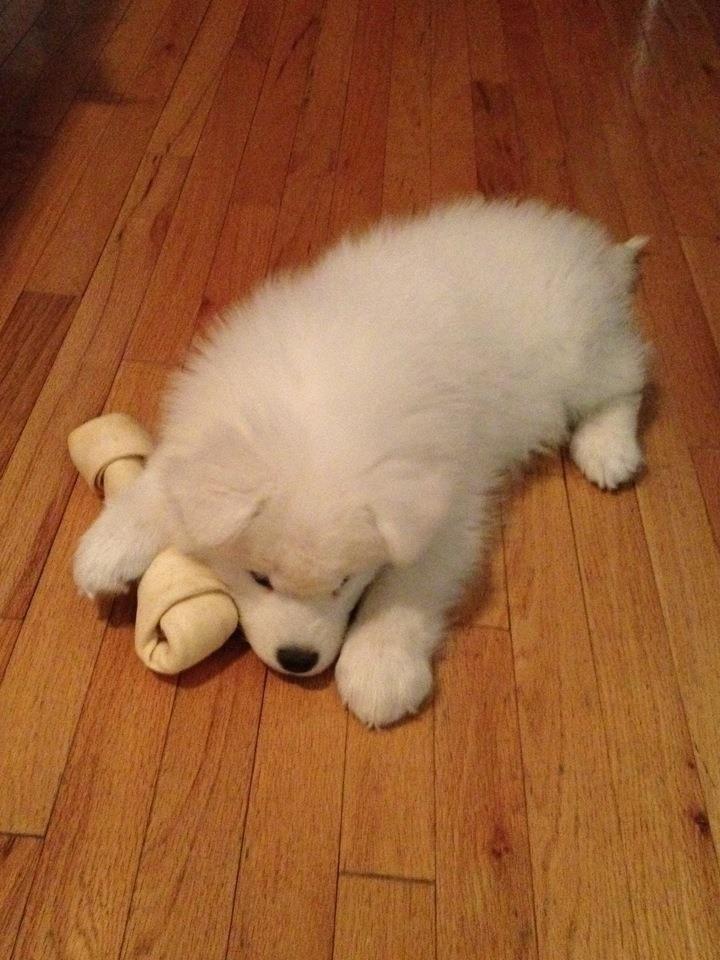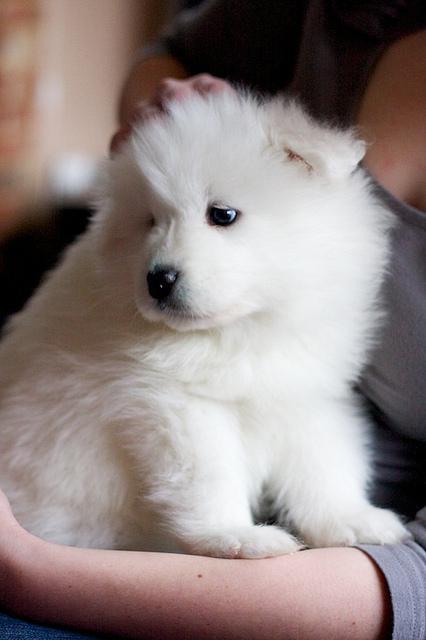The first image is the image on the left, the second image is the image on the right. Analyze the images presented: Is the assertion "one of the pictures has a human arm in it" valid? Answer yes or no. Yes. The first image is the image on the left, the second image is the image on the right. Examine the images to the left and right. Is the description "One of the white dogs is awake and with a person." accurate? Answer yes or no. Yes. 